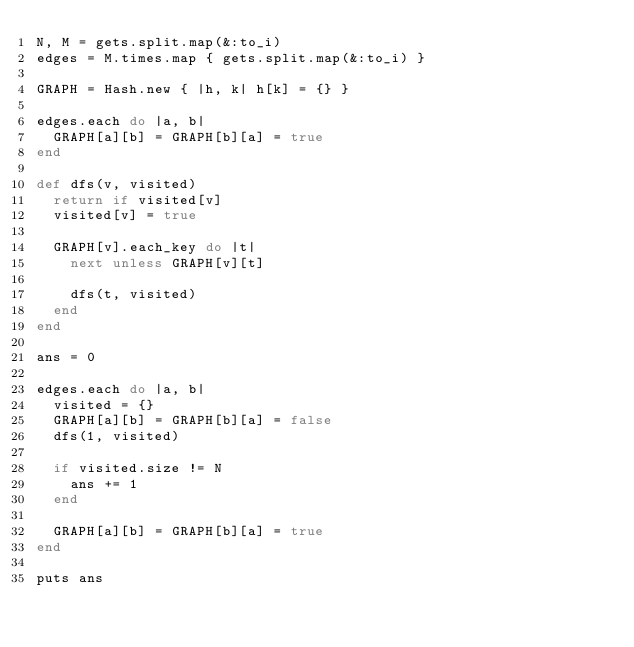Convert code to text. <code><loc_0><loc_0><loc_500><loc_500><_Ruby_>N, M = gets.split.map(&:to_i)
edges = M.times.map { gets.split.map(&:to_i) }

GRAPH = Hash.new { |h, k| h[k] = {} }

edges.each do |a, b|
  GRAPH[a][b] = GRAPH[b][a] = true
end

def dfs(v, visited)
  return if visited[v]
  visited[v] = true

  GRAPH[v].each_key do |t|
    next unless GRAPH[v][t]

    dfs(t, visited)
  end
end

ans = 0

edges.each do |a, b|
  visited = {}
  GRAPH[a][b] = GRAPH[b][a] = false
  dfs(1, visited)

  if visited.size != N
    ans += 1
  end

  GRAPH[a][b] = GRAPH[b][a] = true
end

puts ans
</code> 